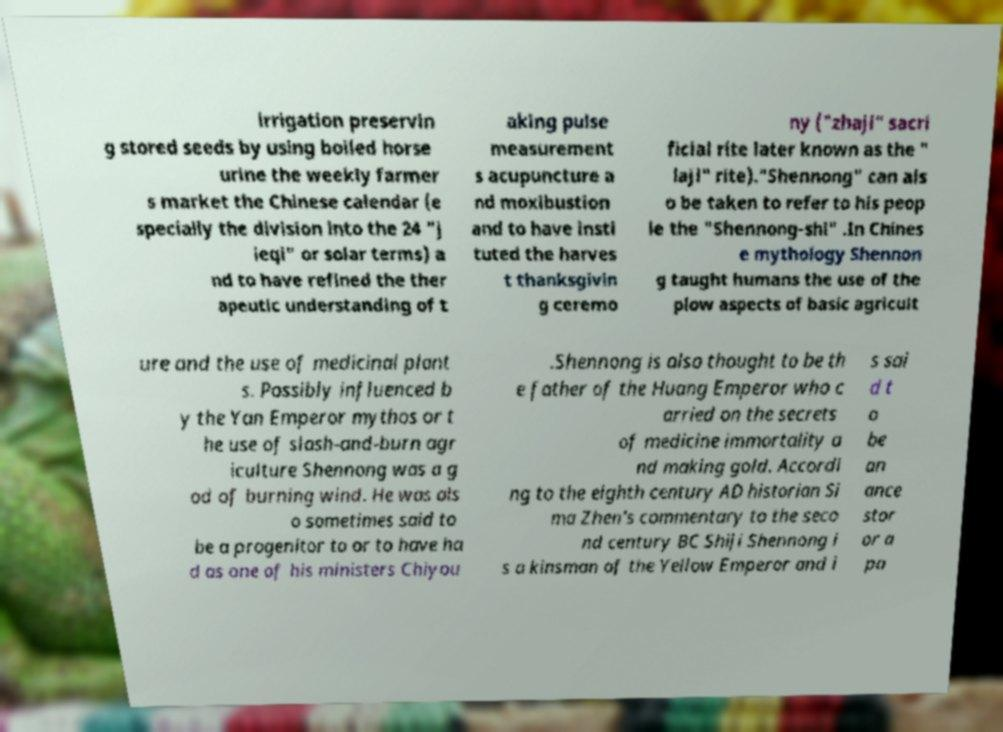Please identify and transcribe the text found in this image. irrigation preservin g stored seeds by using boiled horse urine the weekly farmer s market the Chinese calendar (e specially the division into the 24 "j ieqi" or solar terms) a nd to have refined the ther apeutic understanding of t aking pulse measurement s acupuncture a nd moxibustion and to have insti tuted the harves t thanksgivin g ceremo ny ("zhaji" sacri ficial rite later known as the " laji" rite)."Shennong" can als o be taken to refer to his peop le the "Shennong-shi" .In Chines e mythology Shennon g taught humans the use of the plow aspects of basic agricult ure and the use of medicinal plant s. Possibly influenced b y the Yan Emperor mythos or t he use of slash-and-burn agr iculture Shennong was a g od of burning wind. He was als o sometimes said to be a progenitor to or to have ha d as one of his ministers Chiyou .Shennong is also thought to be th e father of the Huang Emperor who c arried on the secrets of medicine immortality a nd making gold. Accordi ng to the eighth century AD historian Si ma Zhen's commentary to the seco nd century BC Shiji Shennong i s a kinsman of the Yellow Emperor and i s sai d t o be an ance stor or a pa 